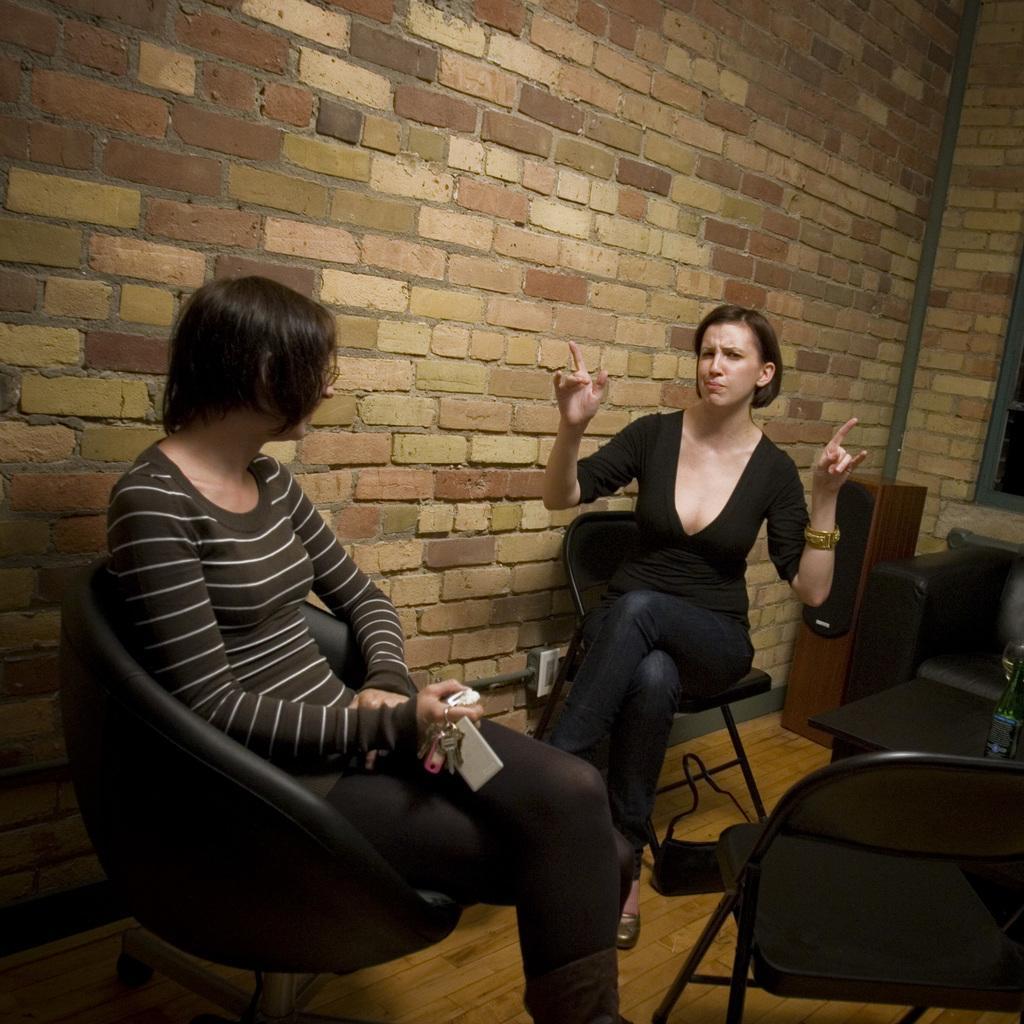In one or two sentences, can you explain what this image depicts? These two people are sitting on chairs. On this table there is a bottle. This woman is holding the keys. On wooden floor there is a bag. This is speaker.  